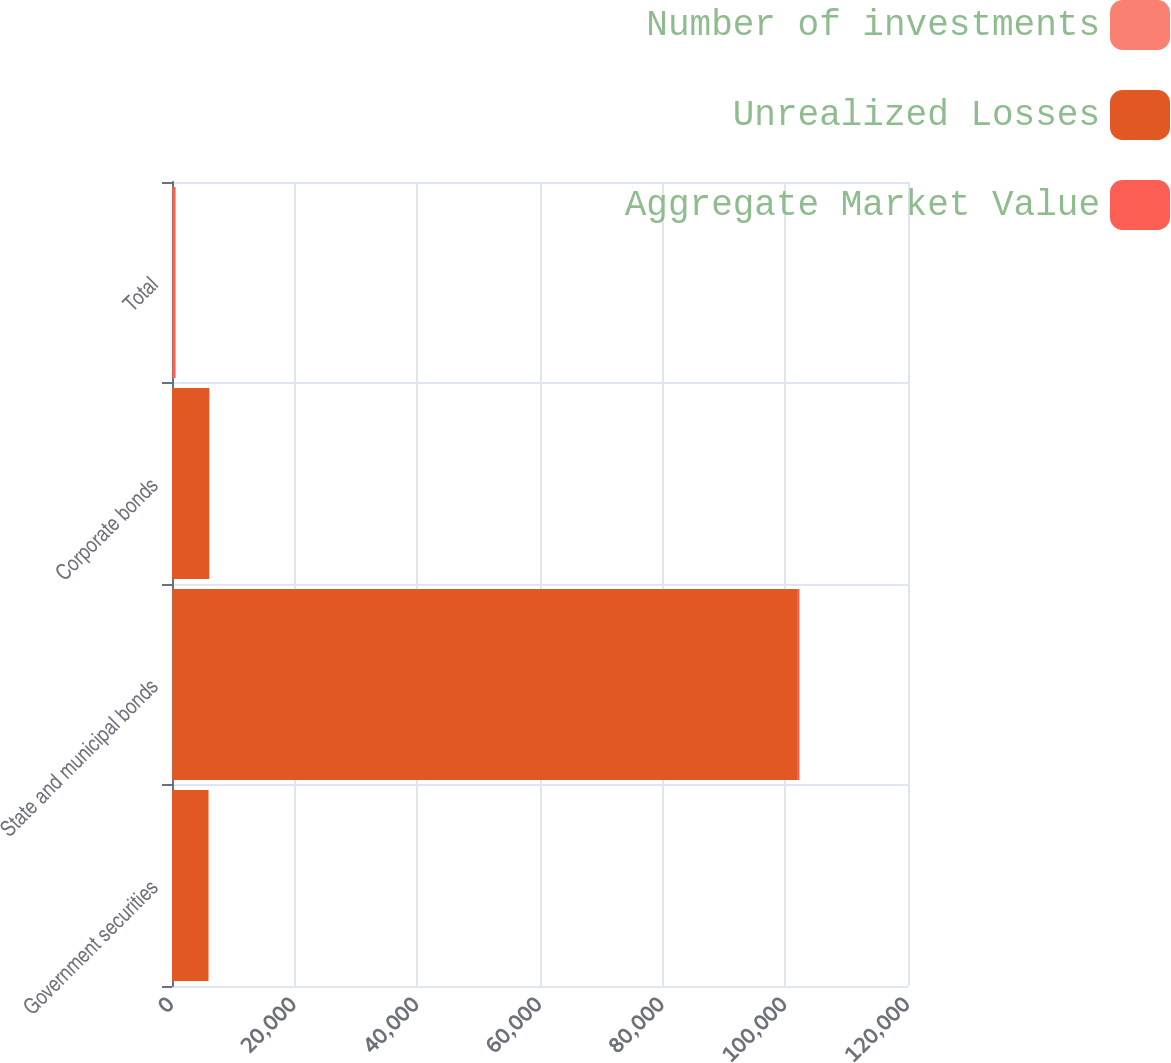Convert chart. <chart><loc_0><loc_0><loc_500><loc_500><stacked_bar_chart><ecel><fcel>Government securities<fcel>State and municipal bonds<fcel>Corporate bonds<fcel>Total<nl><fcel>Number of investments<fcel>1<fcel>50<fcel>2<fcel>53<nl><fcel>Unrealized Losses<fcel>5954<fcel>101851<fcel>6034<fcel>61<nl><fcel>Aggregate Market Value<fcel>4<fcel>396<fcel>61<fcel>461<nl></chart> 